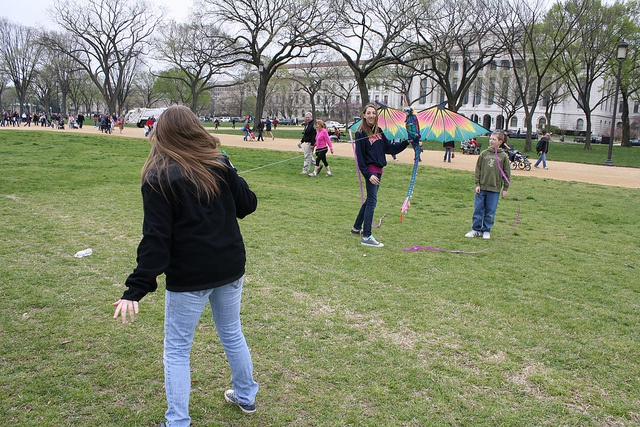Describe the objects in this image and their specific colors. I can see people in lavender, black, darkgray, and gray tones, people in lavender, gray, black, darkgray, and lightgray tones, kite in lavender, lightpink, khaki, darkgray, and teal tones, people in lavender, black, navy, and gray tones, and people in lavender, gray, blue, black, and navy tones in this image. 